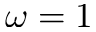<formula> <loc_0><loc_0><loc_500><loc_500>\omega = 1</formula> 